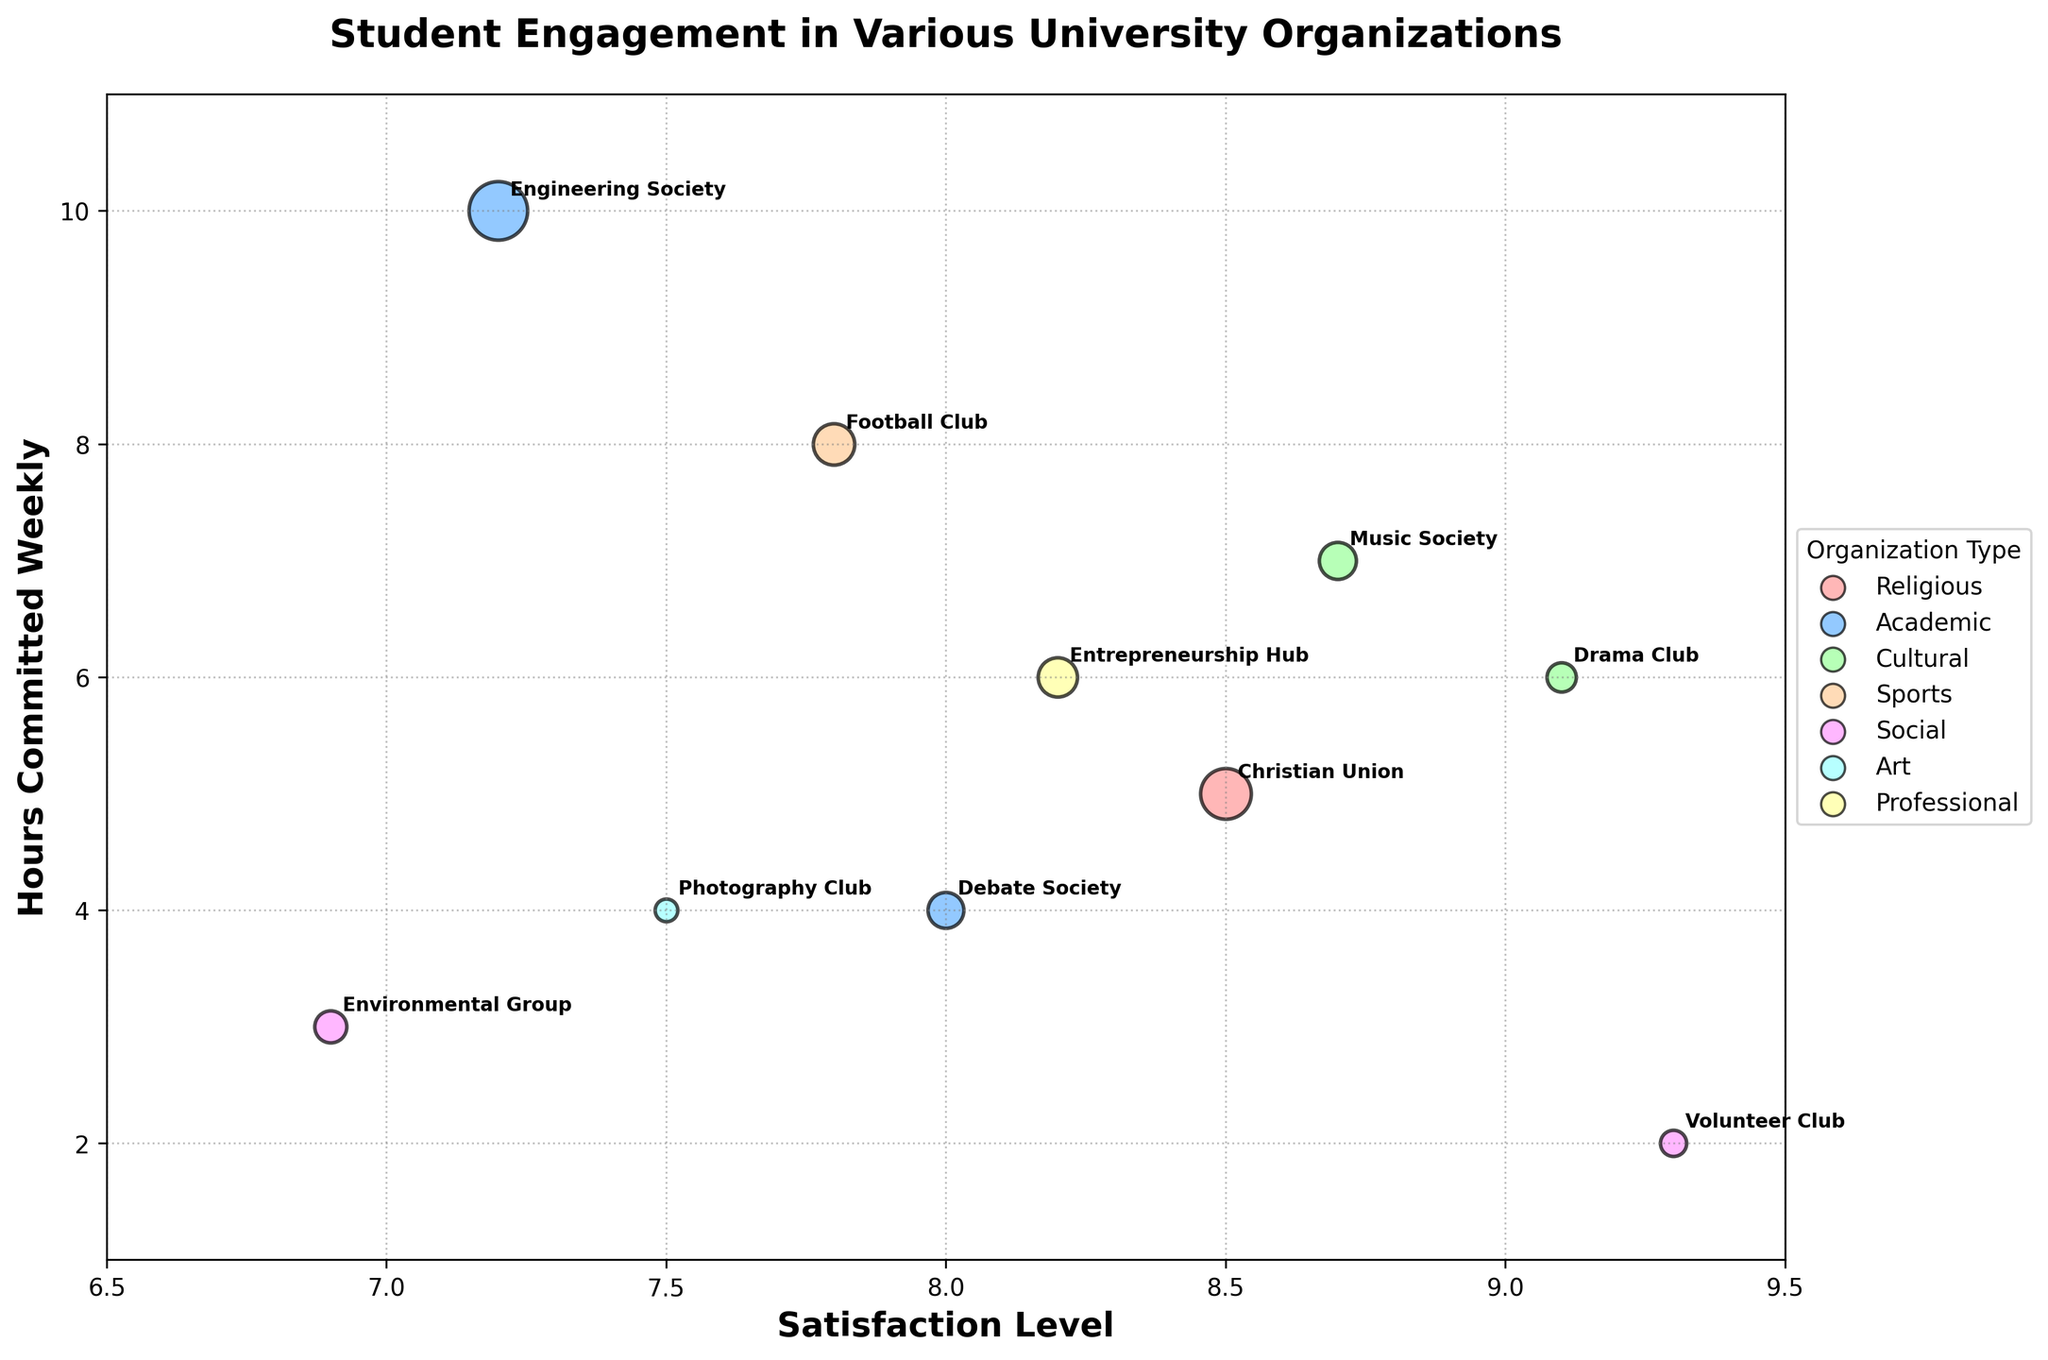What is the title of the figure? The title is located at the top of the figure.
Answer: Student Engagement in Various University Organizations What is the satisfaction level of the Christian Union? Look for the Christian Union bubble and locate its position on the x-axis.
Answer: 8.5 Which organization has the highest number of members? Identify the bubble with the largest size by visual inspection.
Answer: Engineering Society What type of organization is represented by the color green? Check the legend on the right side of the figure.
Answer: Cultural What is the average satisfaction level of all organizations? Sum the satisfaction levels of all organizations (8.5+7.2+9.1+7.8+8.0+6.9+8.7+9.3+7.5+8.2) = 81.2. Divide by the number of organizations (10).
Answer: 8.12 Which organization requires the least weekly hours committed? Identify the bubble positioned lowest on the y-axis.
Answer: Volunteer Club How does the satisfaction level of the Drama Club compare to the average satisfaction level? Calculate the average satisfaction level (8.12) and compare it to the satisfaction level of the Drama Club (9.1). 9.1 > 8.12
Answer: Higher Which academic organization has the highest satisfaction level? Compare the satisfaction levels of the Academic organizations (Engineering Society: 7.2, Debate Society: 8.0).
Answer: Debate Society What is the relation between the size of an organization and the weekly hours committed? Observe the general trend on the figure to see how the bubbles representing the size are distributed along the y-axis of weekly hours committed.
Answer: No clear relation, varies Which organization has a higher satisfaction level, Music Society or Football Club? Compare the satisfaction levels of Music Society (8.7) and Football Club (7.8).
Answer: Music Society 